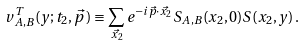Convert formula to latex. <formula><loc_0><loc_0><loc_500><loc_500>v _ { A , B } ^ { T } ( y ; t _ { 2 } , \vec { p } \, ) \equiv \sum _ { \vec { x _ { 2 } } } e ^ { - i \vec { p } \cdot \vec { x _ { 2 } } } S _ { A , B } ( x _ { 2 } , 0 ) S ( x _ { 2 } , y ) \, .</formula> 